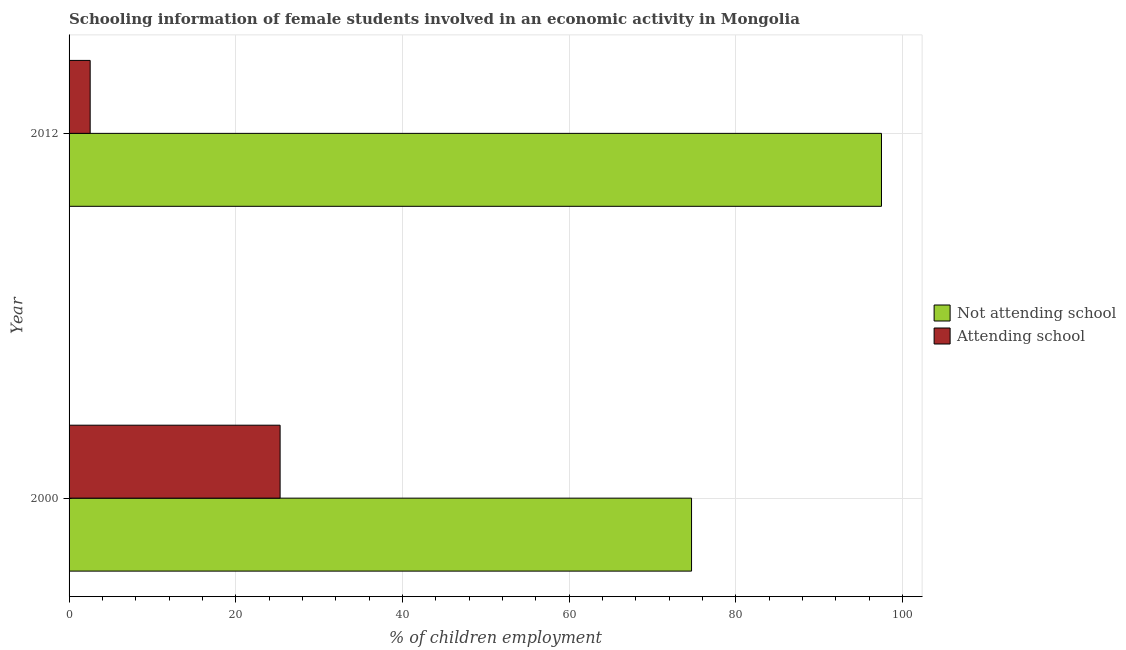How many different coloured bars are there?
Keep it short and to the point. 2. Are the number of bars per tick equal to the number of legend labels?
Your response must be concise. Yes. Are the number of bars on each tick of the Y-axis equal?
Keep it short and to the point. Yes. How many bars are there on the 1st tick from the bottom?
Make the answer very short. 2. What is the label of the 1st group of bars from the top?
Your response must be concise. 2012. In how many cases, is the number of bars for a given year not equal to the number of legend labels?
Provide a succinct answer. 0. What is the percentage of employed females who are not attending school in 2012?
Your answer should be compact. 97.47. Across all years, what is the maximum percentage of employed females who are attending school?
Give a very brief answer. 25.32. Across all years, what is the minimum percentage of employed females who are attending school?
Your response must be concise. 2.53. What is the total percentage of employed females who are not attending school in the graph?
Provide a succinct answer. 172.15. What is the difference between the percentage of employed females who are attending school in 2000 and that in 2012?
Offer a terse response. 22.79. What is the difference between the percentage of employed females who are attending school in 2000 and the percentage of employed females who are not attending school in 2012?
Offer a terse response. -72.15. What is the average percentage of employed females who are not attending school per year?
Your answer should be compact. 86.08. In the year 2012, what is the difference between the percentage of employed females who are attending school and percentage of employed females who are not attending school?
Your answer should be very brief. -94.94. In how many years, is the percentage of employed females who are attending school greater than 8 %?
Give a very brief answer. 1. What is the ratio of the percentage of employed females who are not attending school in 2000 to that in 2012?
Keep it short and to the point. 0.77. Is the percentage of employed females who are not attending school in 2000 less than that in 2012?
Give a very brief answer. Yes. What does the 1st bar from the top in 2012 represents?
Offer a very short reply. Attending school. What does the 2nd bar from the bottom in 2000 represents?
Provide a short and direct response. Attending school. How many bars are there?
Make the answer very short. 4. How many years are there in the graph?
Make the answer very short. 2. Does the graph contain grids?
Offer a terse response. Yes. How are the legend labels stacked?
Keep it short and to the point. Vertical. What is the title of the graph?
Offer a terse response. Schooling information of female students involved in an economic activity in Mongolia. Does "Investments" appear as one of the legend labels in the graph?
Offer a very short reply. No. What is the label or title of the X-axis?
Provide a short and direct response. % of children employment. What is the % of children employment of Not attending school in 2000?
Offer a terse response. 74.68. What is the % of children employment in Attending school in 2000?
Make the answer very short. 25.32. What is the % of children employment of Not attending school in 2012?
Give a very brief answer. 97.47. What is the % of children employment of Attending school in 2012?
Offer a very short reply. 2.53. Across all years, what is the maximum % of children employment in Not attending school?
Offer a very short reply. 97.47. Across all years, what is the maximum % of children employment in Attending school?
Make the answer very short. 25.32. Across all years, what is the minimum % of children employment in Not attending school?
Provide a succinct answer. 74.68. Across all years, what is the minimum % of children employment of Attending school?
Make the answer very short. 2.53. What is the total % of children employment in Not attending school in the graph?
Offer a very short reply. 172.15. What is the total % of children employment in Attending school in the graph?
Provide a short and direct response. 27.85. What is the difference between the % of children employment of Not attending school in 2000 and that in 2012?
Offer a very short reply. -22.79. What is the difference between the % of children employment of Attending school in 2000 and that in 2012?
Provide a succinct answer. 22.79. What is the difference between the % of children employment of Not attending school in 2000 and the % of children employment of Attending school in 2012?
Make the answer very short. 72.15. What is the average % of children employment of Not attending school per year?
Ensure brevity in your answer.  86.08. What is the average % of children employment of Attending school per year?
Give a very brief answer. 13.93. In the year 2000, what is the difference between the % of children employment of Not attending school and % of children employment of Attending school?
Give a very brief answer. 49.36. In the year 2012, what is the difference between the % of children employment in Not attending school and % of children employment in Attending school?
Give a very brief answer. 94.94. What is the ratio of the % of children employment of Not attending school in 2000 to that in 2012?
Make the answer very short. 0.77. What is the ratio of the % of children employment of Attending school in 2000 to that in 2012?
Ensure brevity in your answer.  10. What is the difference between the highest and the second highest % of children employment in Not attending school?
Your answer should be very brief. 22.79. What is the difference between the highest and the second highest % of children employment of Attending school?
Give a very brief answer. 22.79. What is the difference between the highest and the lowest % of children employment in Not attending school?
Your answer should be compact. 22.79. What is the difference between the highest and the lowest % of children employment in Attending school?
Your answer should be compact. 22.79. 